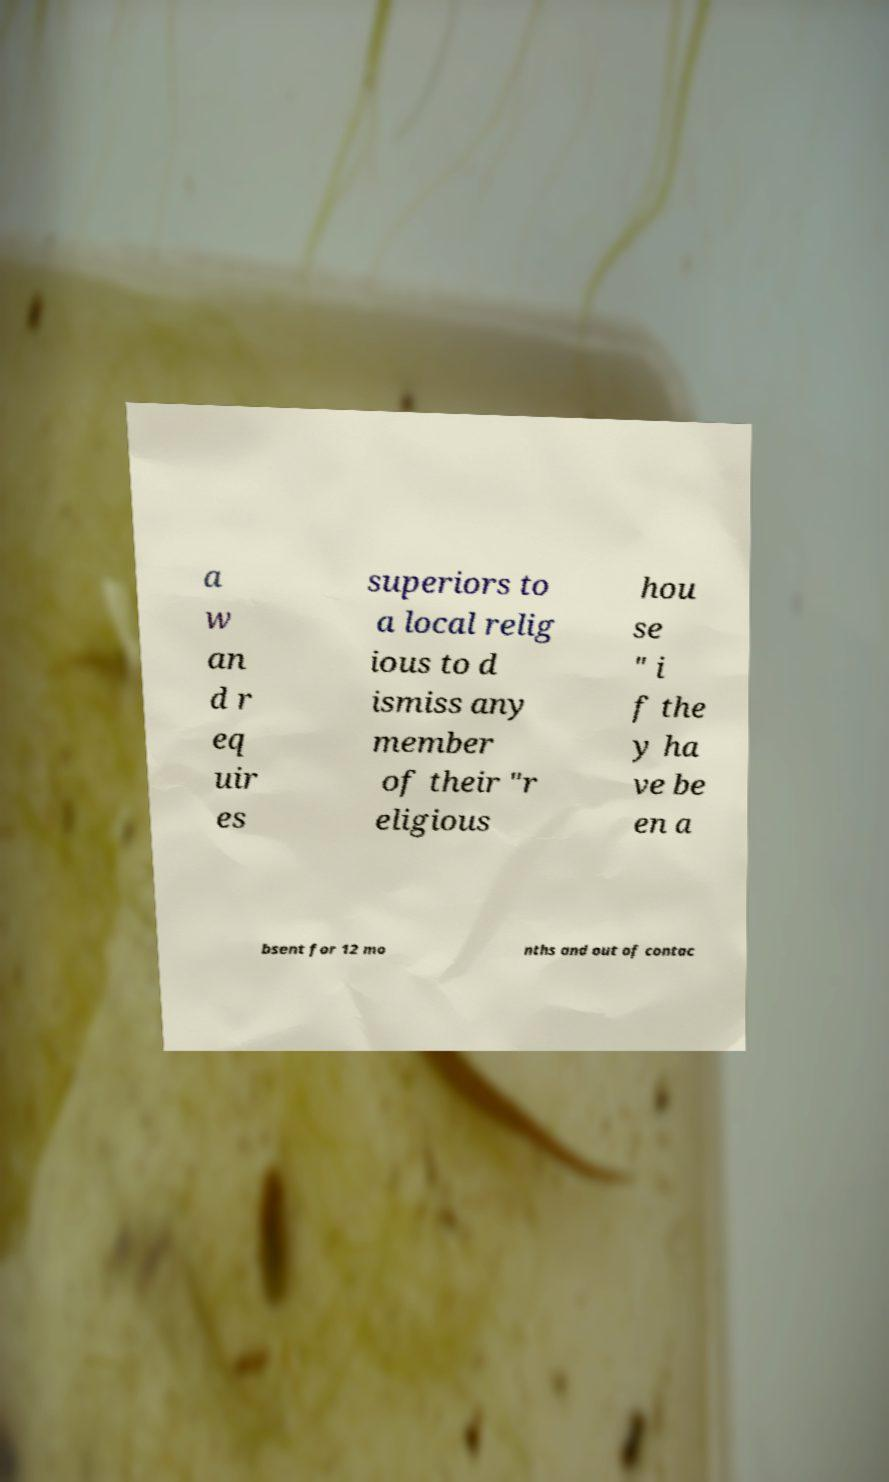Please read and relay the text visible in this image. What does it say? a w an d r eq uir es superiors to a local relig ious to d ismiss any member of their "r eligious hou se " i f the y ha ve be en a bsent for 12 mo nths and out of contac 